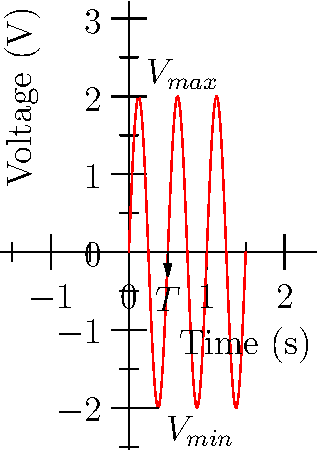As a startup founder working on economic inequality solutions, you're developing a data visualization tool for energy consumption patterns. You encounter a waveform representing voltage fluctuations in a shared solar grid. Based on the graph, determine:

a) The frequency of the waveform in Hz
b) The peak-to-peak amplitude in V Let's approach this step-by-step:

1) Frequency Calculation:
   - Frequency is the inverse of the period (T).
   - From the graph, we can see that one complete cycle occurs in 0.5 seconds.
   - Therefore, T = 0.5 s
   - Frequency (f) = 1/T = 1/0.5 = 2 Hz

2) Peak-to-Peak Amplitude Calculation:
   - The peak-to-peak amplitude is the difference between the maximum and minimum values of the waveform.
   - From the graph:
     Maximum value ($V_{max}$) = 2 V
     Minimum value ($V_{min}$) = -2 V
   - Peak-to-Peak Amplitude = $V_{max} - V_{min}$ = 2 - (-2) = 4 V

This analysis could help in understanding energy fluctuations in your shared solar grid, potentially leading to more efficient energy distribution strategies for addressing economic inequality.
Answer: a) 2 Hz
b) 4 V 